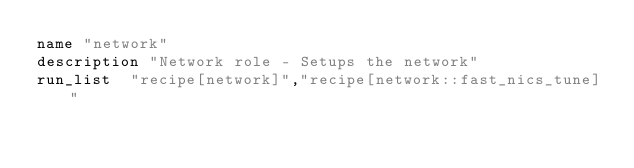Convert code to text. <code><loc_0><loc_0><loc_500><loc_500><_Ruby_>name "network"
description "Network role - Setups the network"
run_list  "recipe[network]","recipe[network::fast_nics_tune]"

</code> 